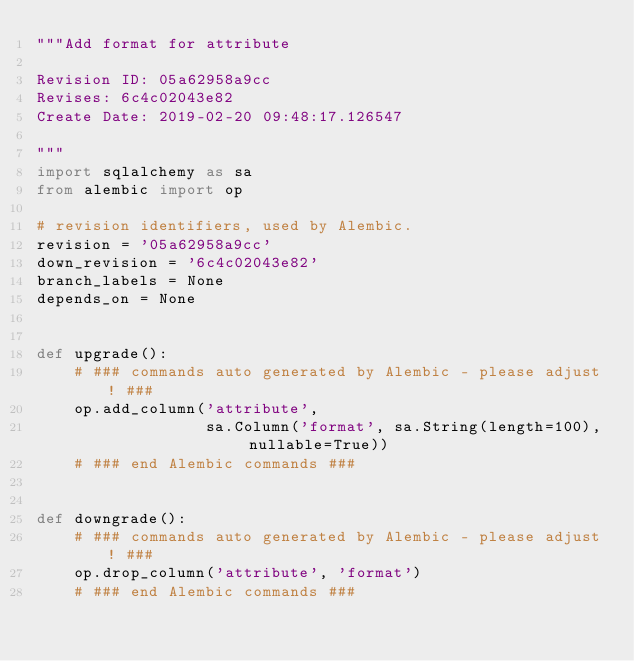Convert code to text. <code><loc_0><loc_0><loc_500><loc_500><_Python_>"""Add format for attribute

Revision ID: 05a62958a9cc
Revises: 6c4c02043e82
Create Date: 2019-02-20 09:48:17.126547

"""
import sqlalchemy as sa
from alembic import op

# revision identifiers, used by Alembic.
revision = '05a62958a9cc'
down_revision = '6c4c02043e82'
branch_labels = None
depends_on = None


def upgrade():
    # ### commands auto generated by Alembic - please adjust! ###
    op.add_column('attribute',
                  sa.Column('format', sa.String(length=100), nullable=True))
    # ### end Alembic commands ###


def downgrade():
    # ### commands auto generated by Alembic - please adjust! ###
    op.drop_column('attribute', 'format')
    # ### end Alembic commands ###
</code> 